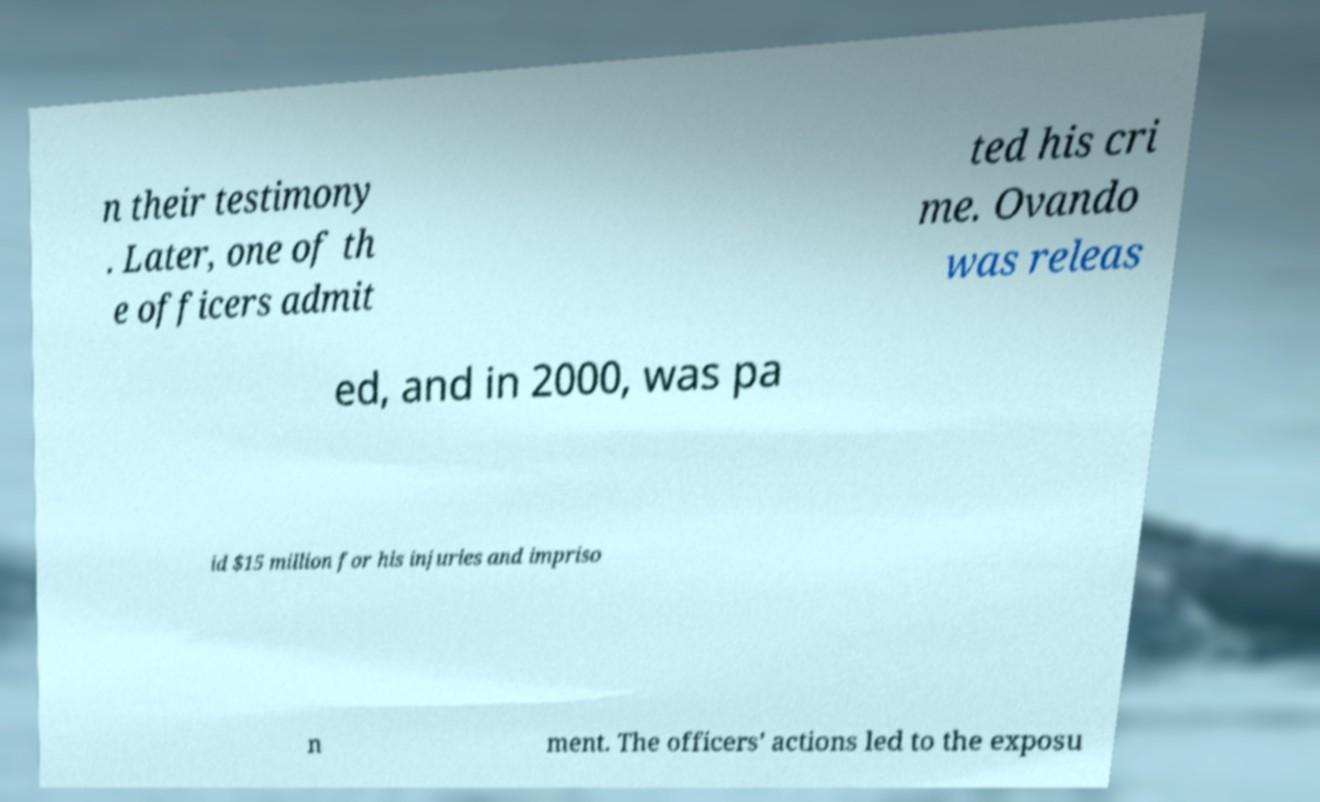Please identify and transcribe the text found in this image. n their testimony . Later, one of th e officers admit ted his cri me. Ovando was releas ed, and in 2000, was pa id $15 million for his injuries and impriso n ment. The officers' actions led to the exposu 